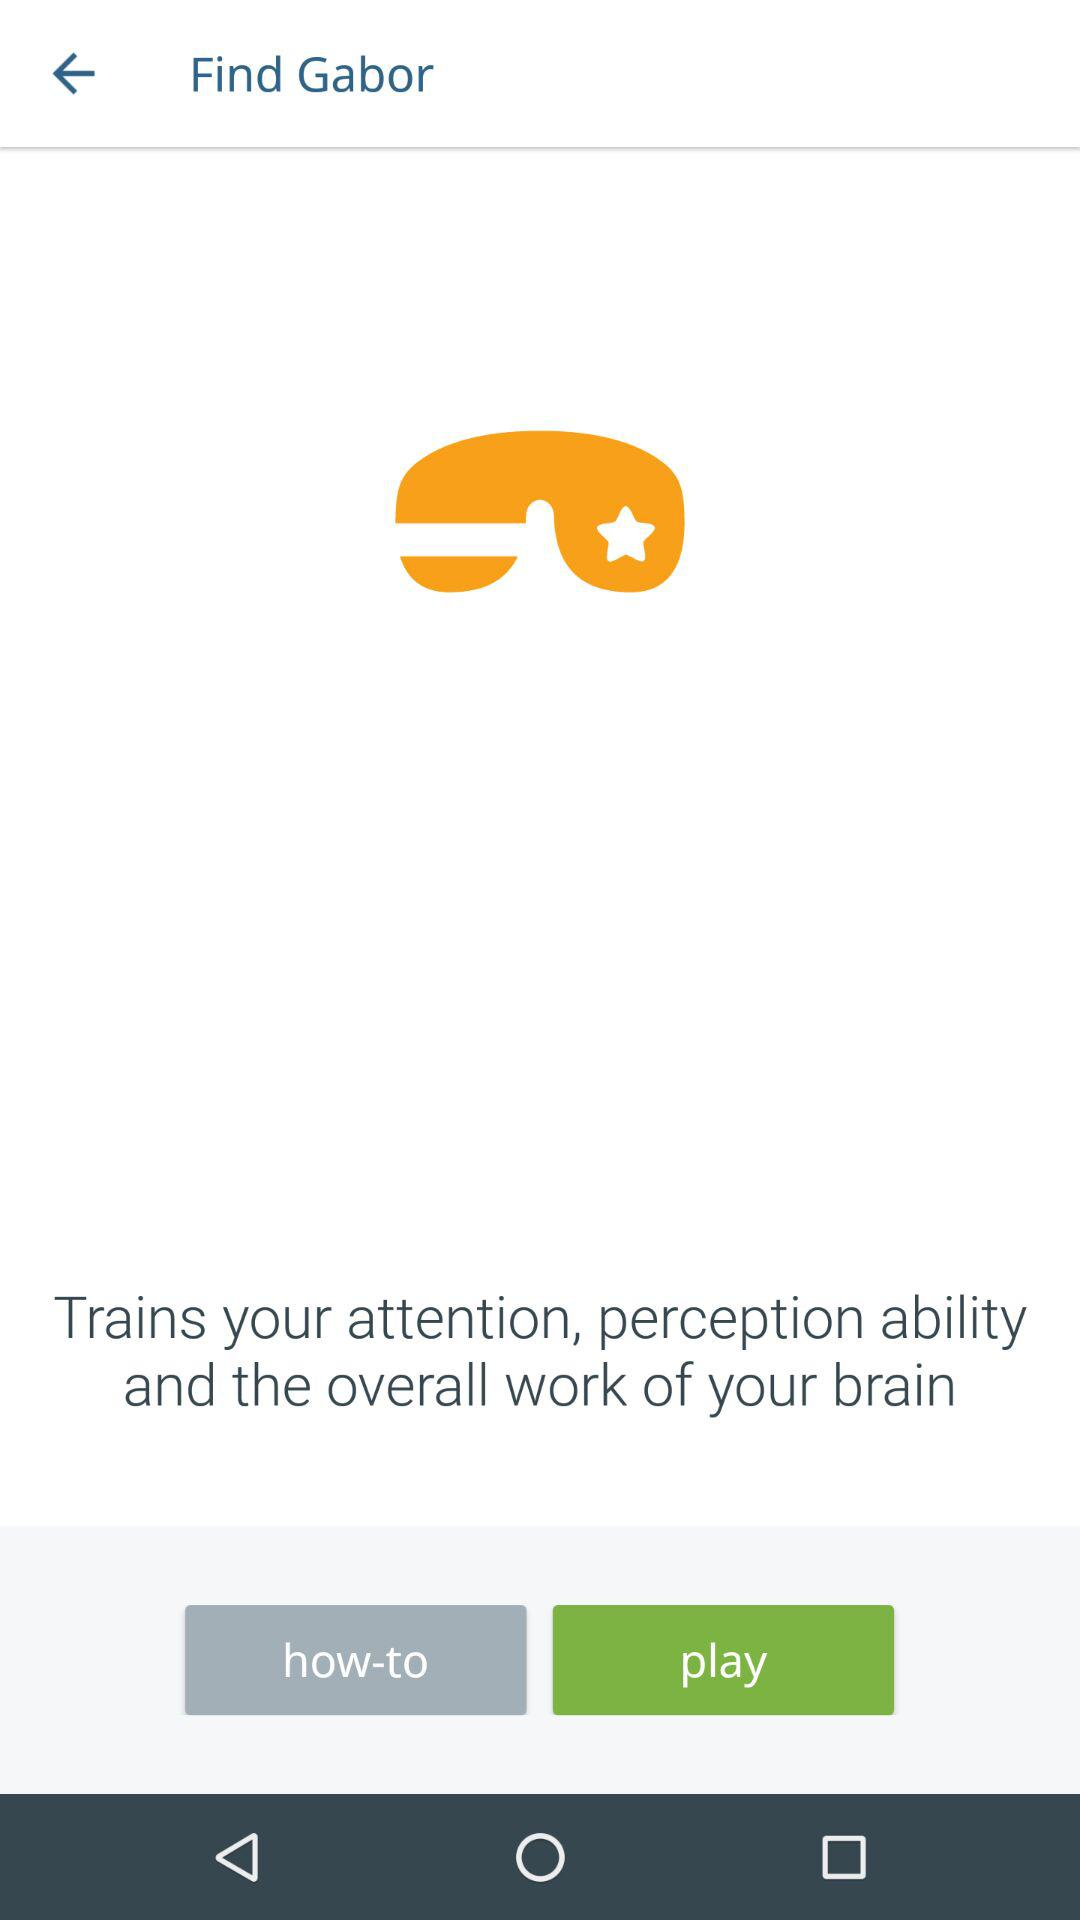What is the name of the application? The name of the application is "Gabor". 